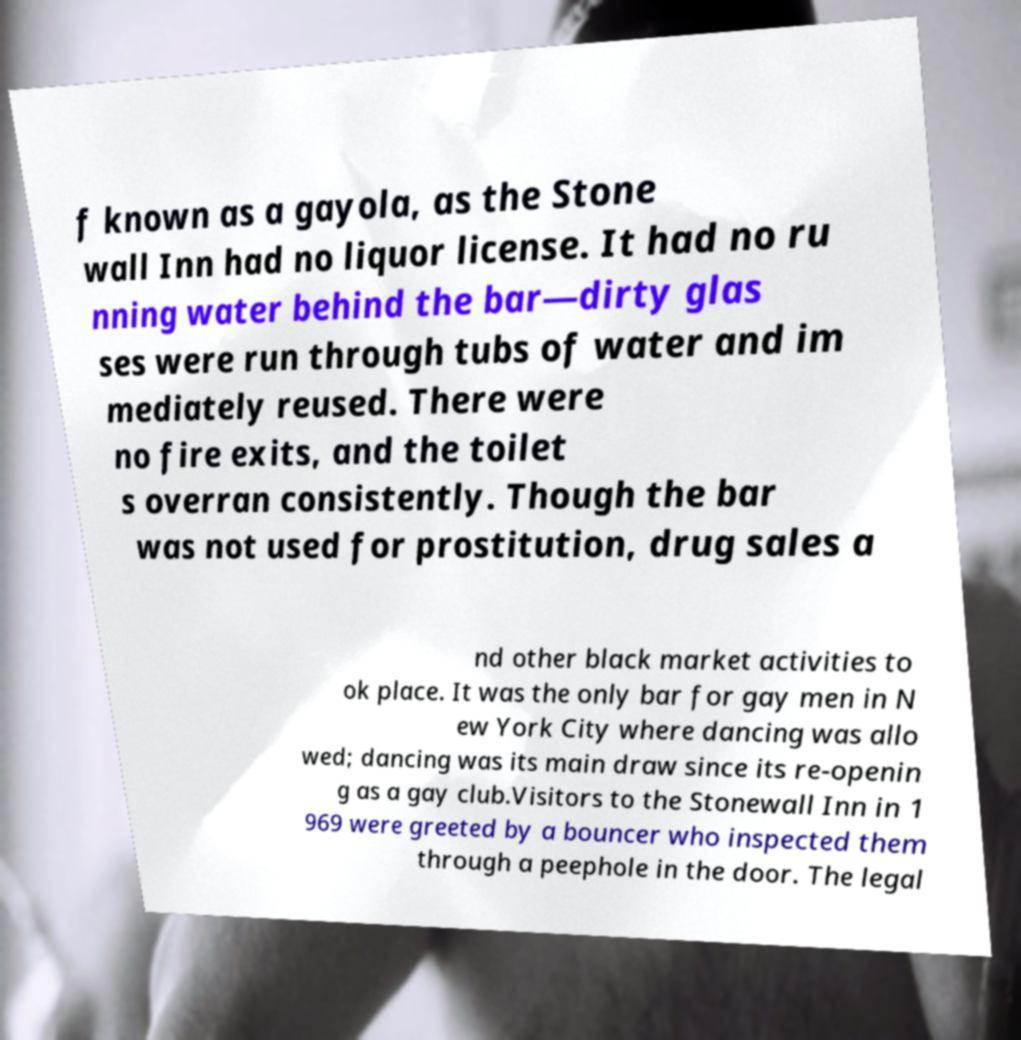For documentation purposes, I need the text within this image transcribed. Could you provide that? f known as a gayola, as the Stone wall Inn had no liquor license. It had no ru nning water behind the bar—dirty glas ses were run through tubs of water and im mediately reused. There were no fire exits, and the toilet s overran consistently. Though the bar was not used for prostitution, drug sales a nd other black market activities to ok place. It was the only bar for gay men in N ew York City where dancing was allo wed; dancing was its main draw since its re-openin g as a gay club.Visitors to the Stonewall Inn in 1 969 were greeted by a bouncer who inspected them through a peephole in the door. The legal 